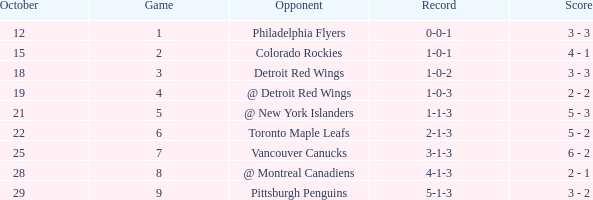Name the least game for october 21 5.0. 